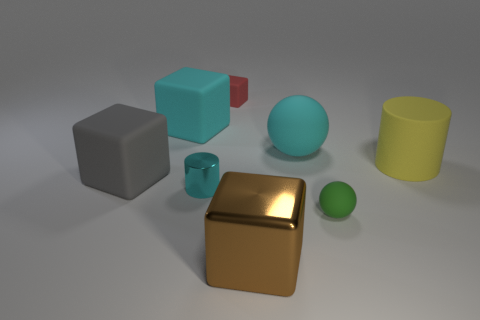Are any small blocks visible?
Make the answer very short. Yes. Are there any other things of the same color as the large matte sphere?
Your answer should be very brief. Yes. There is a big gray object that is made of the same material as the green sphere; what shape is it?
Provide a short and direct response. Cube. There is a small metallic cylinder in front of the cylinder that is right of the block on the right side of the tiny rubber cube; what color is it?
Provide a short and direct response. Cyan. Is the number of small things behind the large yellow rubber cylinder the same as the number of balls?
Your answer should be compact. No. Is there anything else that is made of the same material as the big yellow object?
Your answer should be compact. Yes. Does the large metal thing have the same color as the cylinder that is in front of the yellow matte object?
Your answer should be compact. No. There is a cyan rubber object that is left of the big block that is in front of the big gray object; are there any big rubber balls that are behind it?
Provide a succinct answer. No. Are there fewer cyan cylinders that are in front of the small red matte block than big spheres?
Offer a very short reply. No. What number of other things are there of the same shape as the yellow rubber object?
Your response must be concise. 1. 